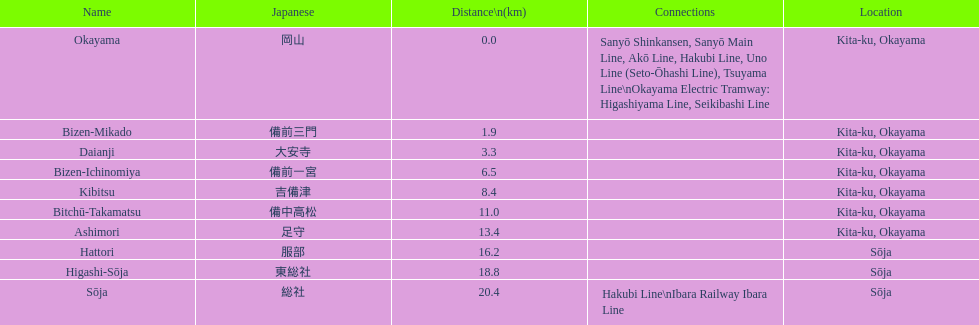Which has the most distance, hattori or kibitsu? Hattori. 